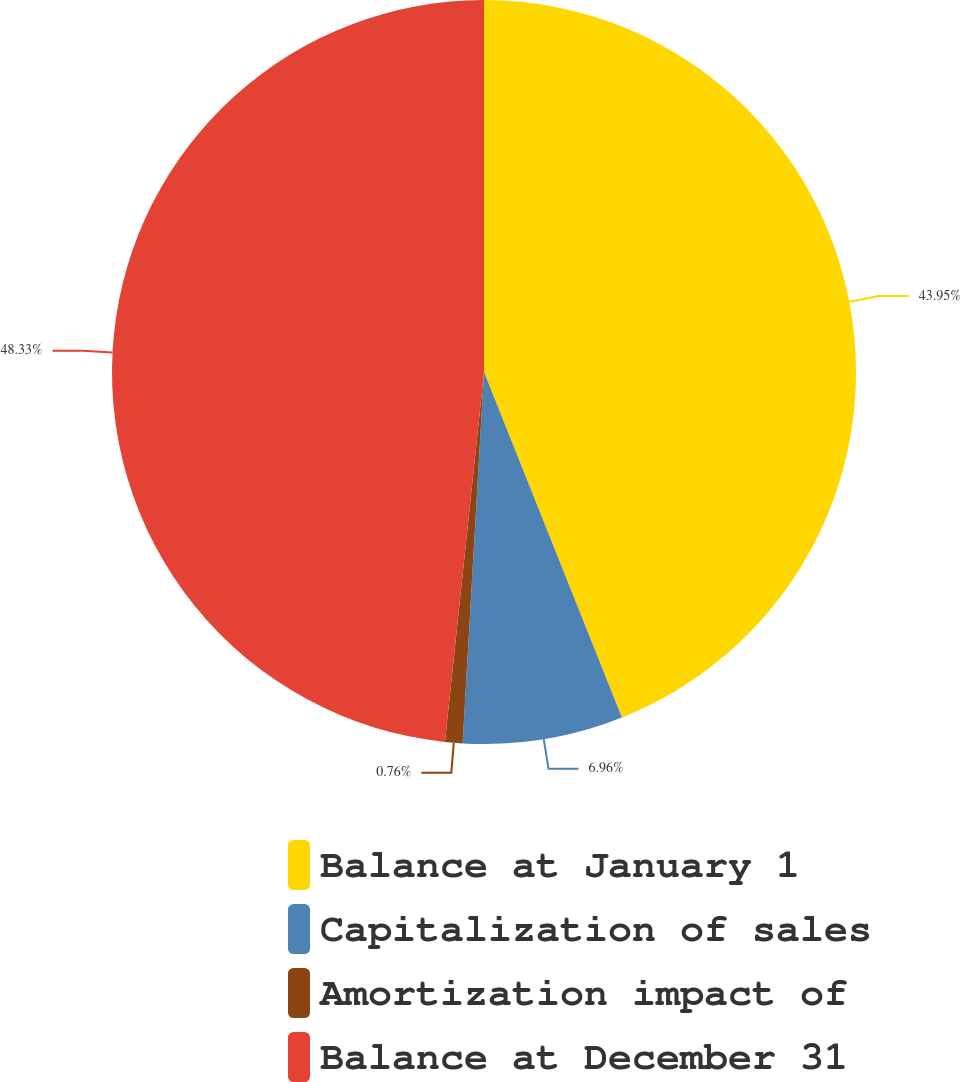<chart> <loc_0><loc_0><loc_500><loc_500><pie_chart><fcel>Balance at January 1<fcel>Capitalization of sales<fcel>Amortization impact of<fcel>Balance at December 31<nl><fcel>43.95%<fcel>6.96%<fcel>0.76%<fcel>48.32%<nl></chart> 